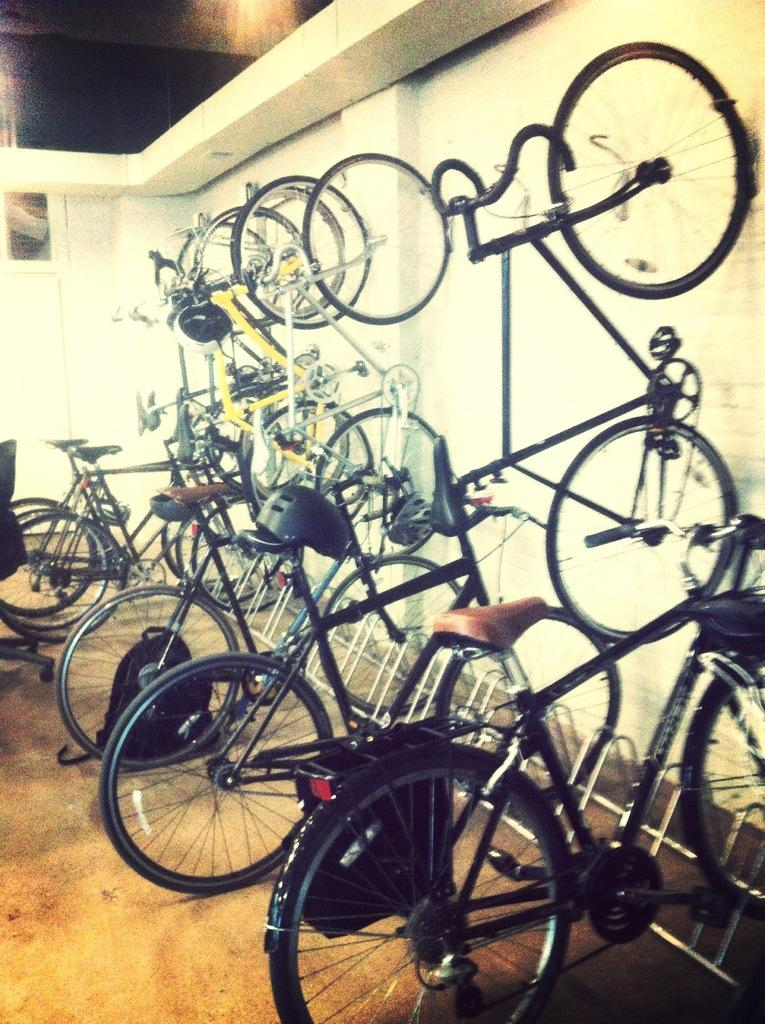What is the main subject in the center of the image? There are bicycles in the center of the image. What can be seen on the right side of the image? There is a wall on the right side of the image. Where is the scarecrow located in the image? There is no scarecrow present in the image. What type of amusement can be seen in the image? There is no amusement depicted in the image; it features bicycles and a wall. 